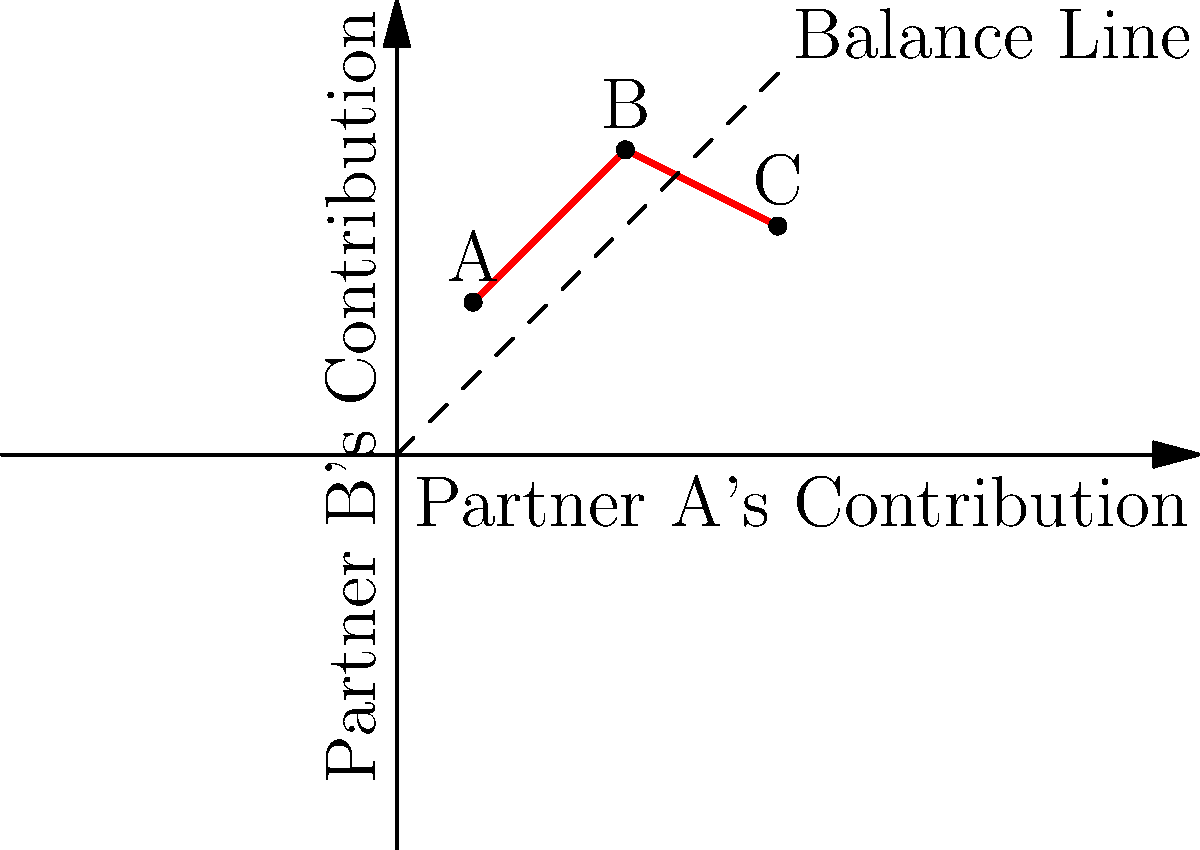In the graph above, the red line represents the balance of give-and-take in a relationship over time, with points A, B, and C showing different stages. The dashed line represents perfect balance. As a relationship counselor, how would you interpret the relationship's progression from point A to point C, and what advice would you give to help the couple achieve better balance? To analyze this graph and provide appropriate advice, let's follow these steps:

1. Interpret each point:
   A (1,2): Partner B contributes more than Partner A
   B (3,4): Both partners increase contributions, but still slightly imbalanced
   C (5,3): Partner A's contribution increases, while Partner B's decreases

2. Analyze the progression:
   A to B: The relationship becomes more balanced as both partners increase their contributions
   B to C: The balance shifts, with Partner A contributing more than Partner B

3. Overall trend:
   The relationship moves from an imbalance favoring Partner B to an imbalance favoring Partner A

4. Advice for better balance:
   a. Encourage open communication about each partner's needs and expectations
   b. Suggest finding a middle ground between points B and C
   c. Recommend regular check-ins to ensure both partners feel valued and heard
   d. Propose creating a list of shared responsibilities to maintain balance
   e. Emphasize the importance of mutual understanding and compromise

5. Cautious approach:
   As a prudent counselor, advise gradual adjustments rather than drastic changes
   Encourage the couple to set realistic goals for achieving balance over time
Answer: Relationship progresses from imbalance favoring Partner B to favoring Partner A. Advise open communication, finding middle ground, regular check-ins, shared responsibilities, and gradual adjustments for better balance. 